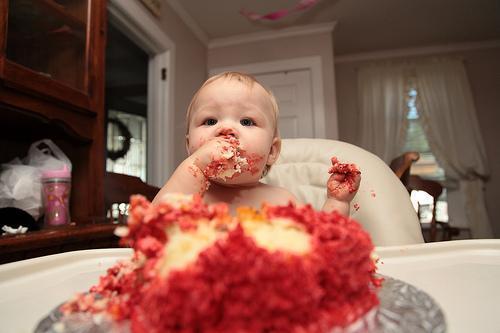How many babies are there in this picture?
Give a very brief answer. 1. 